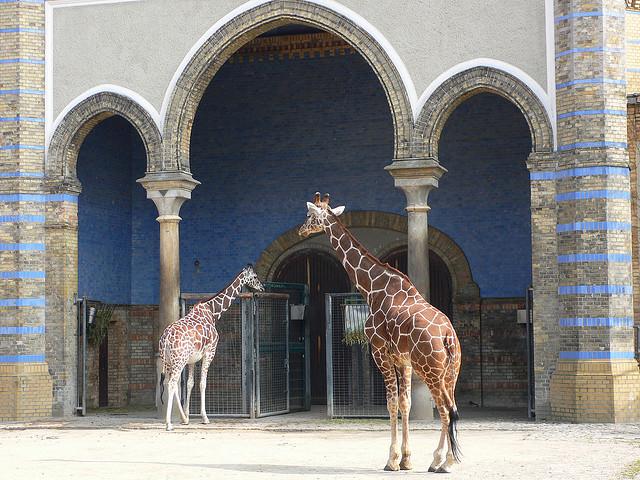How long are the animal's legs?
Answer briefly. 3 feet. Are these animals in 2 different sizes?
Quick response, please. Yes. How many blue stripes are visible?
Keep it brief. 27. 